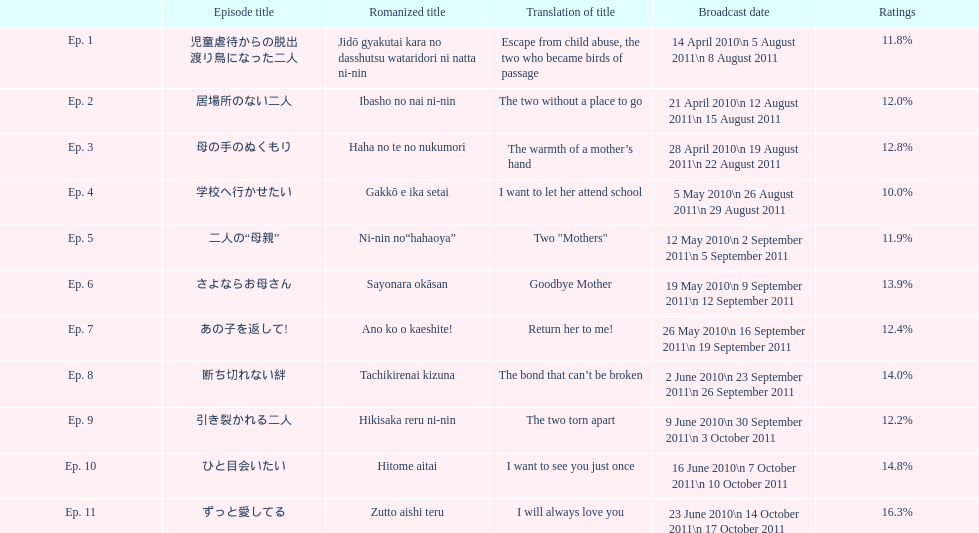What episode number was the unique episode to hold above 16% of ratings? 11. 